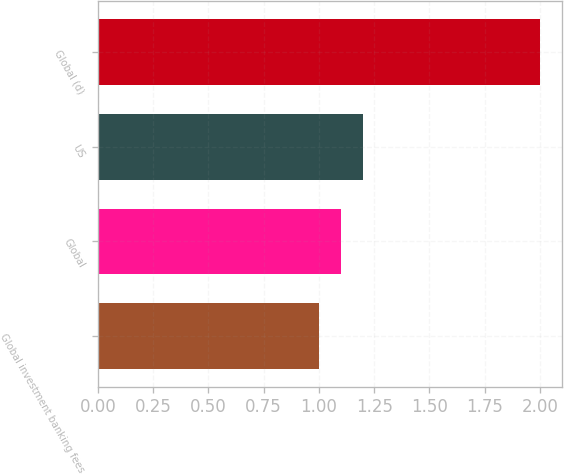<chart> <loc_0><loc_0><loc_500><loc_500><bar_chart><fcel>Global investment banking fees<fcel>Global<fcel>US<fcel>Global (d)<nl><fcel>1<fcel>1.1<fcel>1.2<fcel>2<nl></chart> 